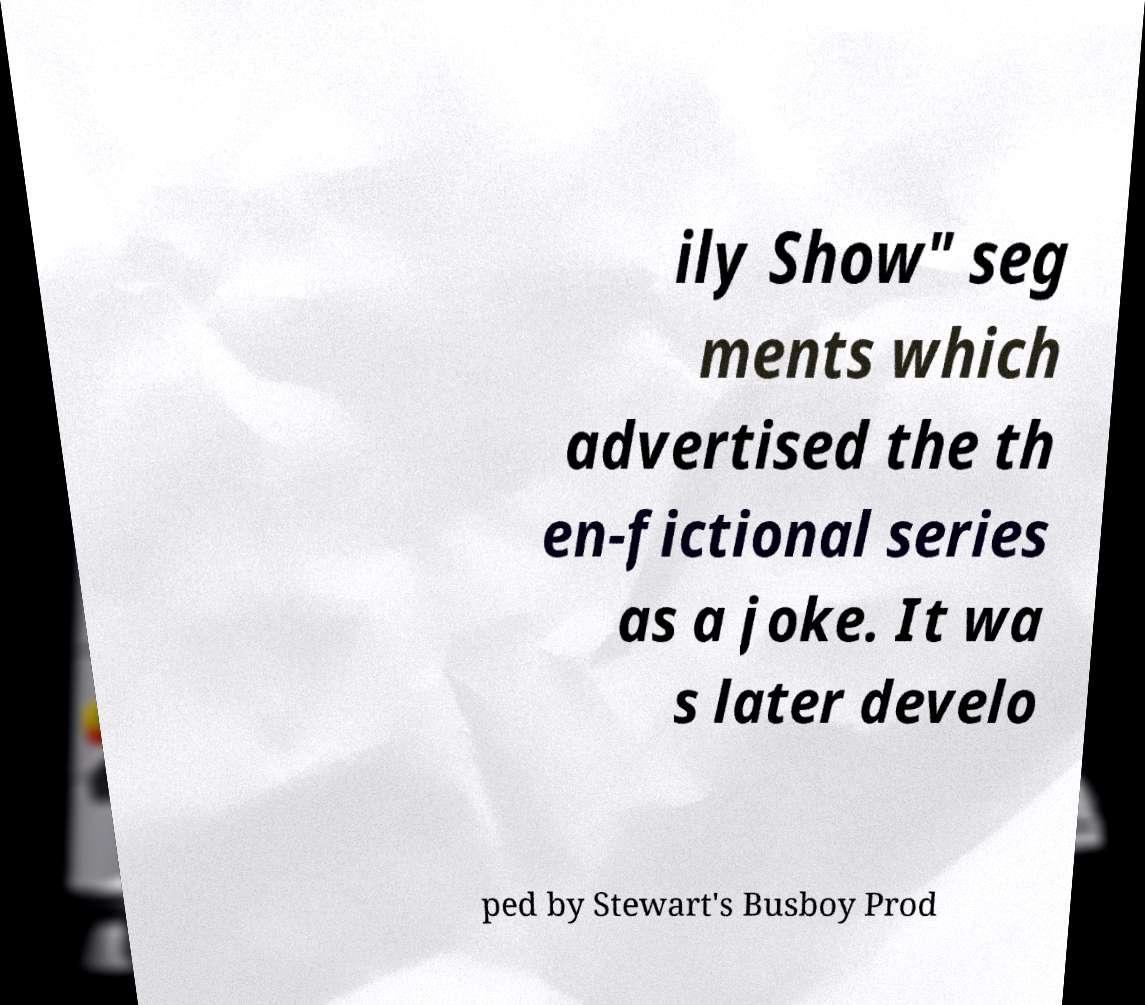For documentation purposes, I need the text within this image transcribed. Could you provide that? ily Show" seg ments which advertised the th en-fictional series as a joke. It wa s later develo ped by Stewart's Busboy Prod 